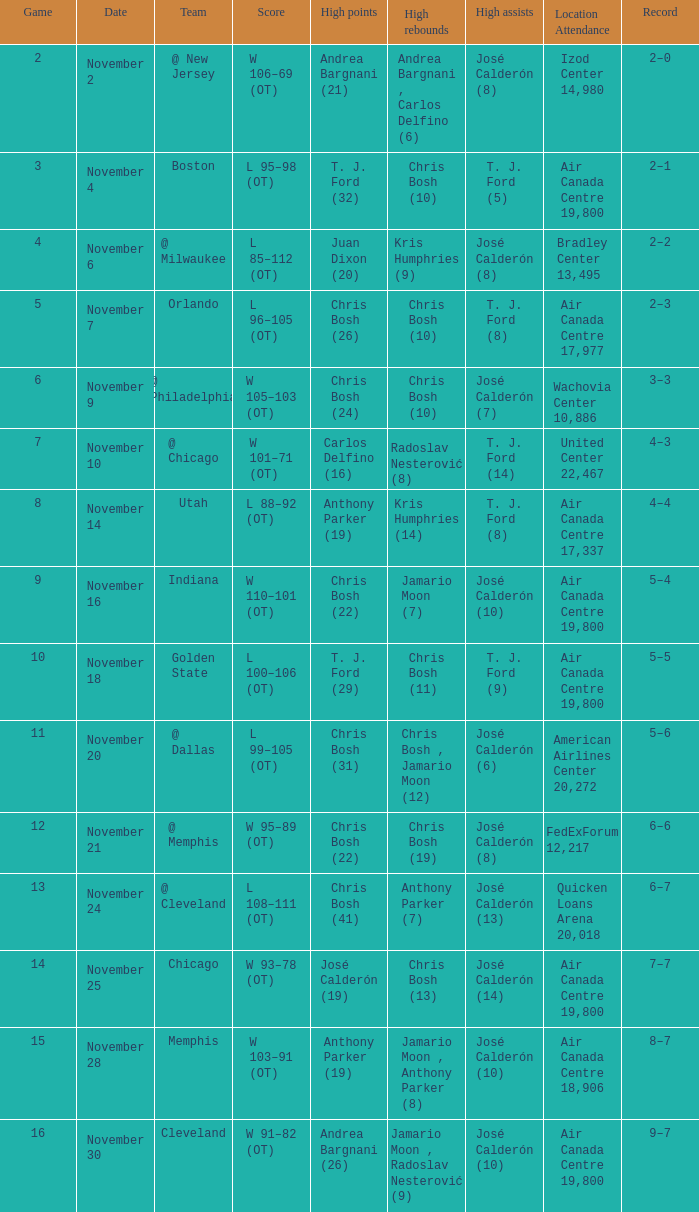What is the score when the team is in cleveland? L 108–111 (OT). 